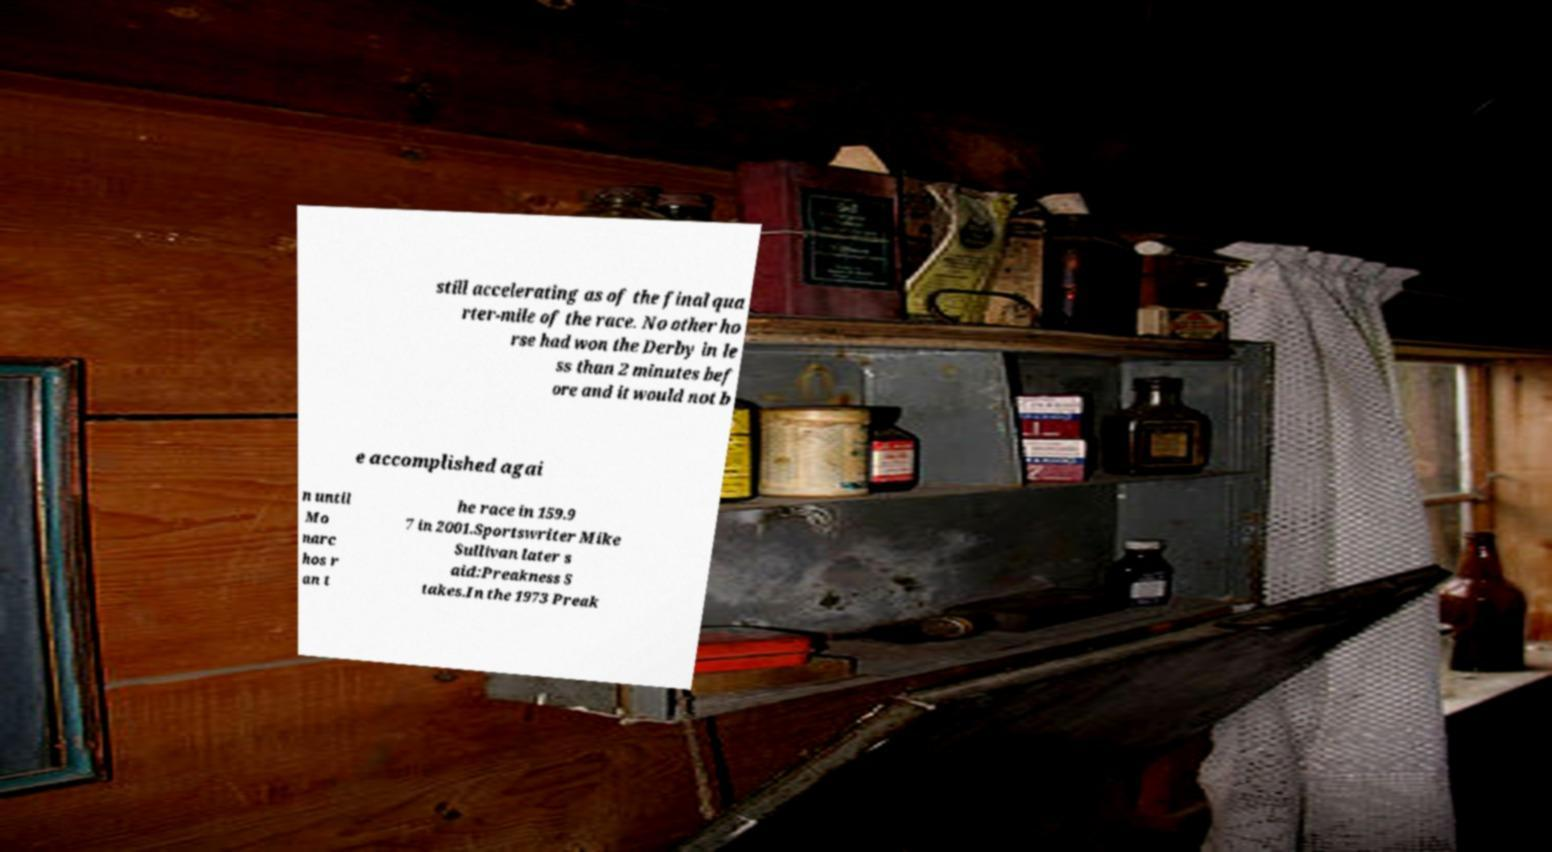For documentation purposes, I need the text within this image transcribed. Could you provide that? still accelerating as of the final qua rter-mile of the race. No other ho rse had won the Derby in le ss than 2 minutes bef ore and it would not b e accomplished agai n until Mo narc hos r an t he race in 159.9 7 in 2001.Sportswriter Mike Sullivan later s aid:Preakness S takes.In the 1973 Preak 